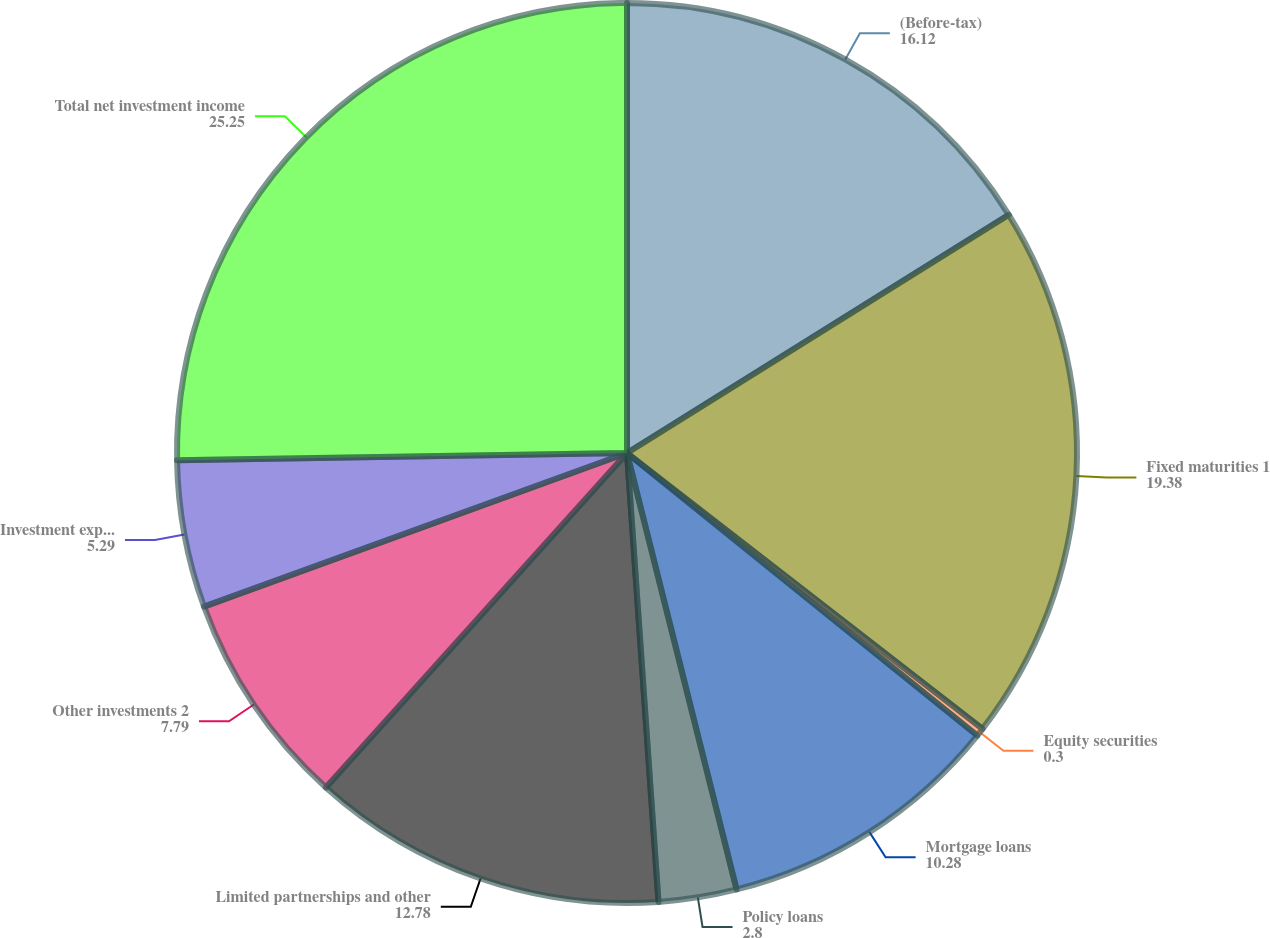Convert chart to OTSL. <chart><loc_0><loc_0><loc_500><loc_500><pie_chart><fcel>(Before-tax)<fcel>Fixed maturities 1<fcel>Equity securities<fcel>Mortgage loans<fcel>Policy loans<fcel>Limited partnerships and other<fcel>Other investments 2<fcel>Investment expenses<fcel>Total net investment income<nl><fcel>16.12%<fcel>19.38%<fcel>0.3%<fcel>10.28%<fcel>2.8%<fcel>12.78%<fcel>7.79%<fcel>5.29%<fcel>25.25%<nl></chart> 